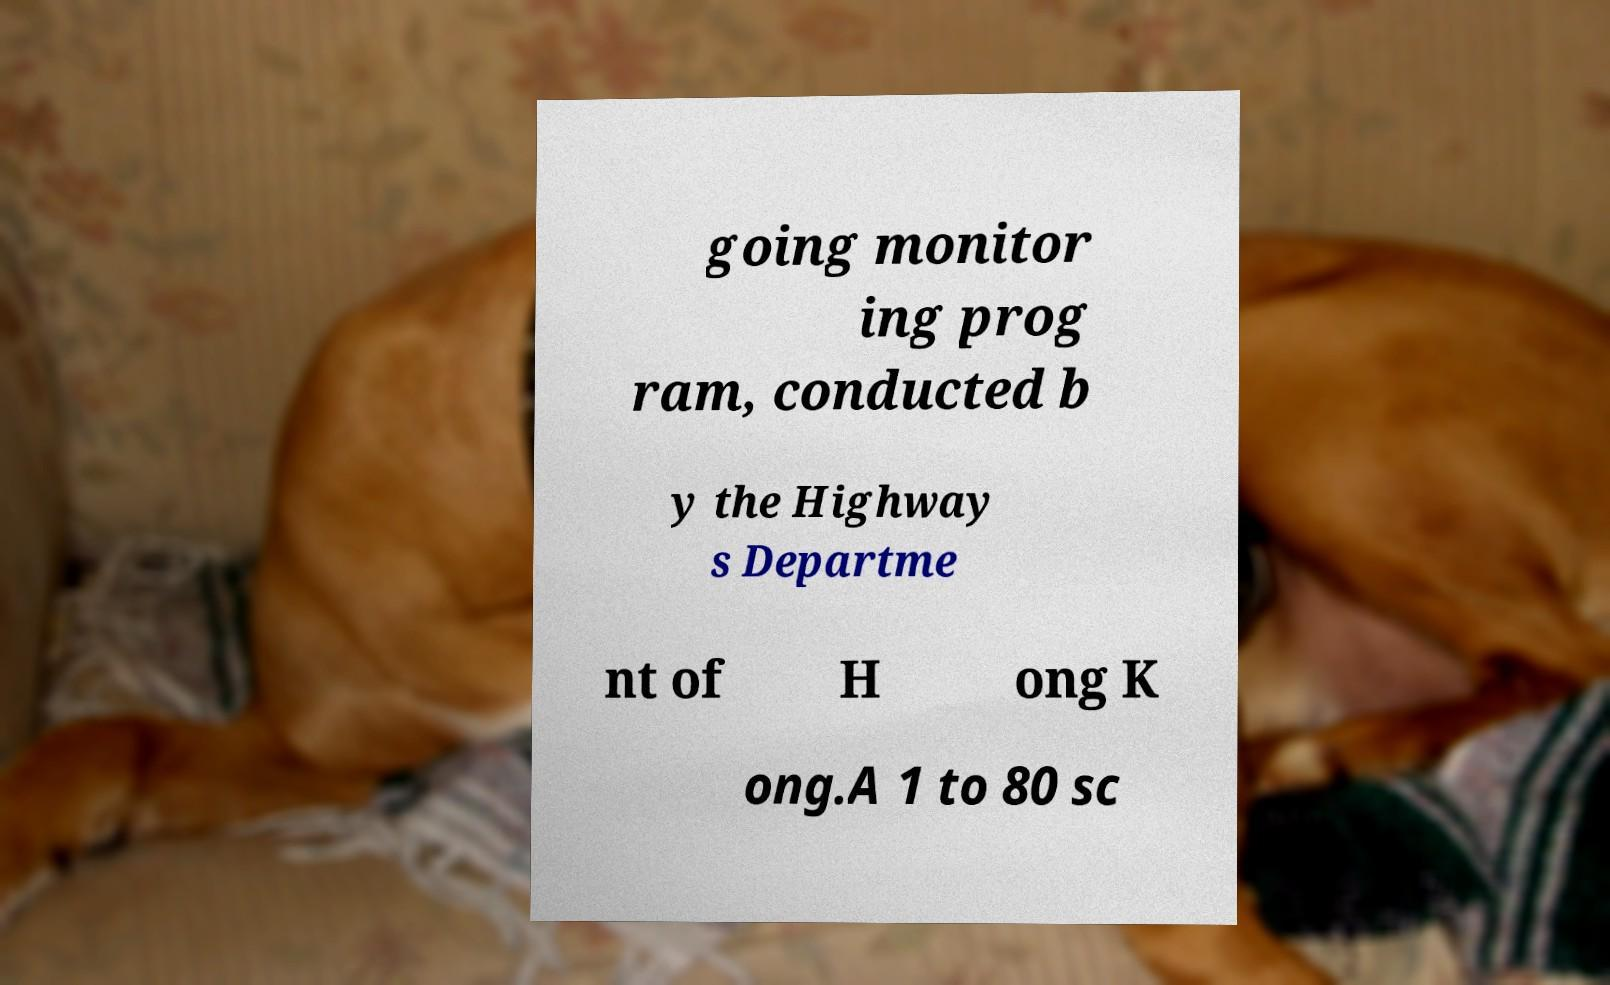For documentation purposes, I need the text within this image transcribed. Could you provide that? going monitor ing prog ram, conducted b y the Highway s Departme nt of H ong K ong.A 1 to 80 sc 